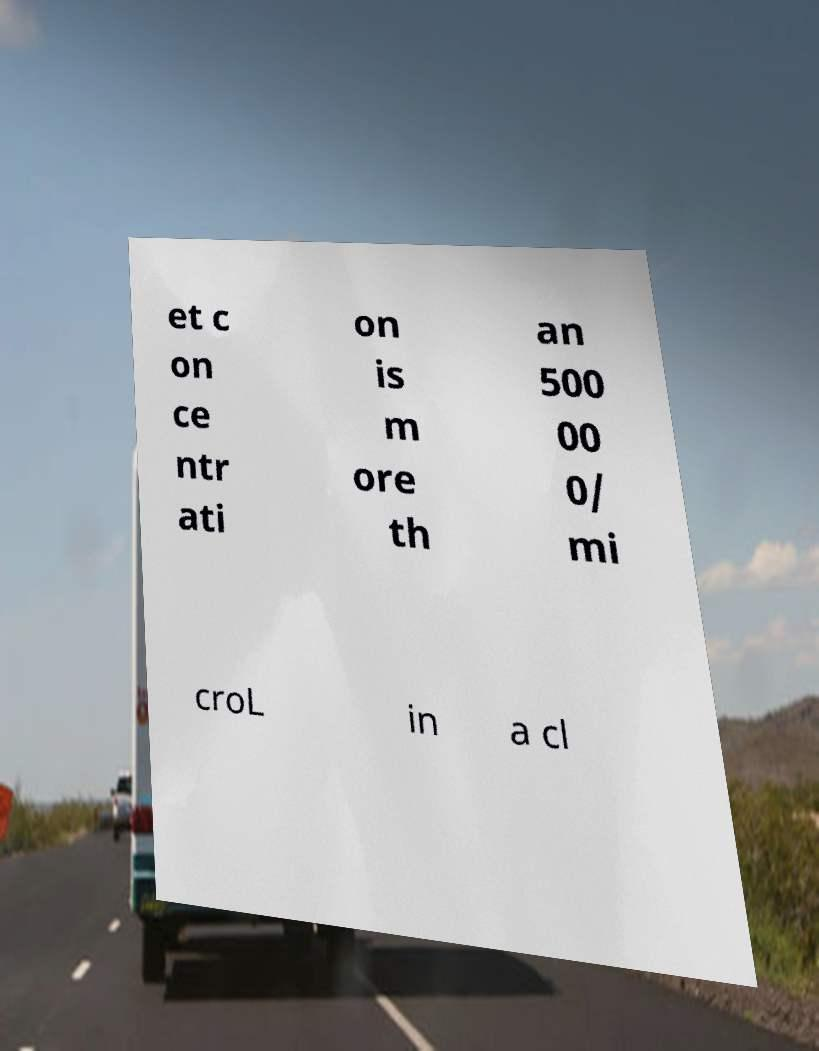Please identify and transcribe the text found in this image. et c on ce ntr ati on is m ore th an 500 00 0/ mi croL in a cl 